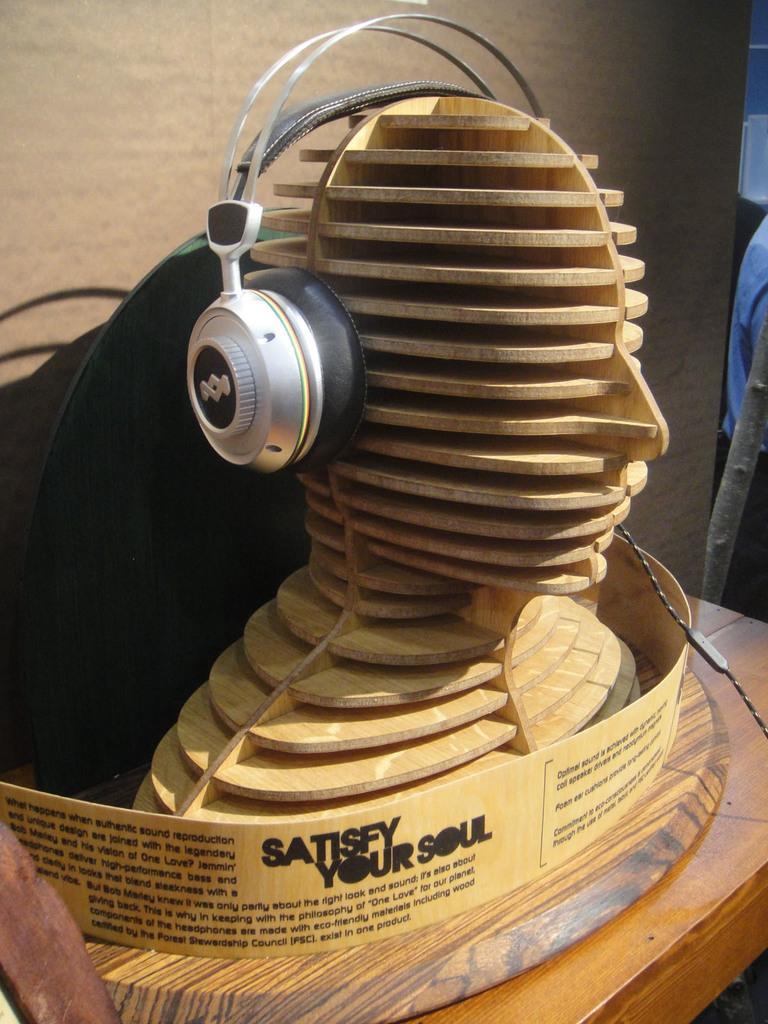Could you give a brief overview of what you see in this image? In the center of the image we can see sculpture and headset placed on the table. In the background there is a wall. 